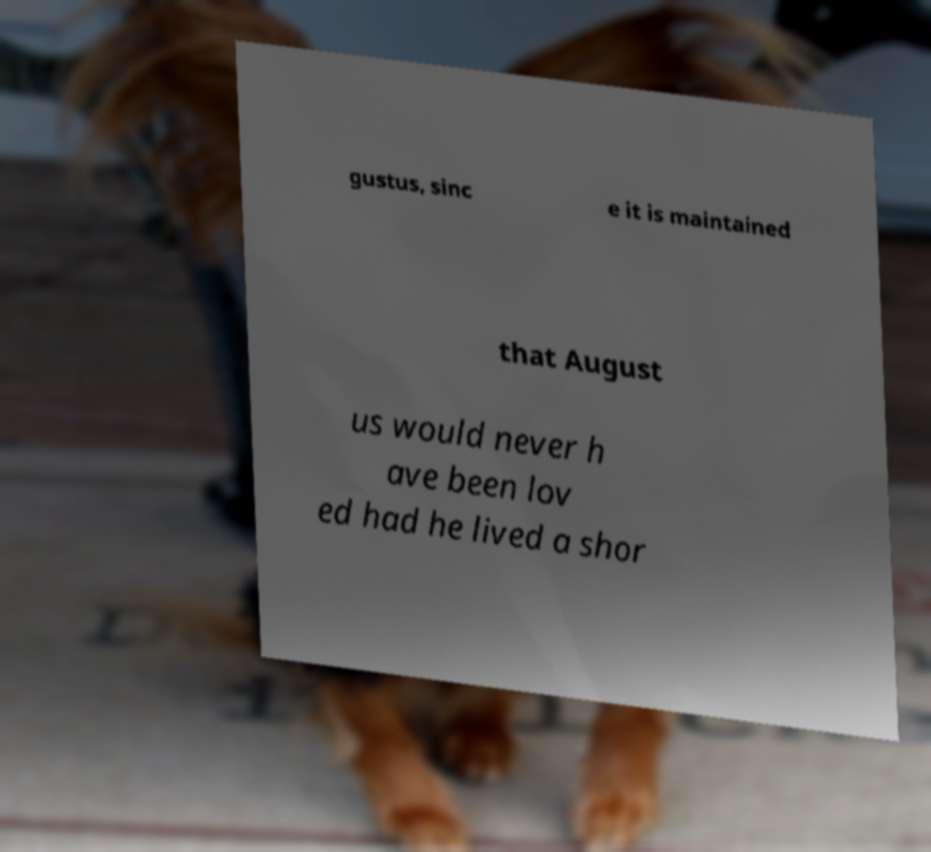I need the written content from this picture converted into text. Can you do that? gustus, sinc e it is maintained that August us would never h ave been lov ed had he lived a shor 